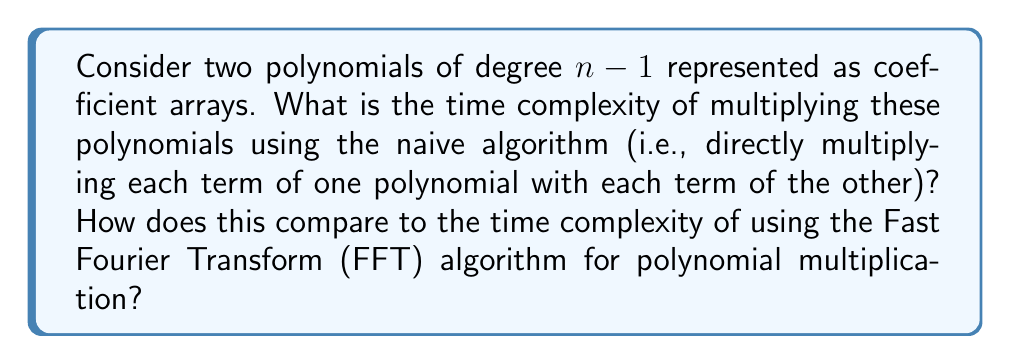Show me your answer to this math problem. To analyze the time complexity of polynomial multiplication algorithms, we need to consider the number of operations performed:

1. Naive Algorithm:
   - For two polynomials of degree $n-1$, we have $n$ coefficients in each polynomial.
   - We need to multiply each coefficient of the first polynomial with each coefficient of the second polynomial.
   - This results in $n \times n = n^2$ multiplications.
   - We also need to sum up the products for each resulting coefficient, which takes $O(n^2)$ additions.
   - Therefore, the total time complexity is $O(n^2)$.

2. Fast Fourier Transform (FFT) Algorithm:
   - The FFT algorithm converts the polynomials to point-value representation.
   - It then performs pointwise multiplication and converts back to coefficient representation.
   - The steps are:
     a) Apply FFT to both polynomials: $O(n \log n)$ each
     b) Multiply the resulting points: $O(n)$
     c) Apply inverse FFT to get the result: $O(n \log n)$
   - The total time complexity is $O(n \log n)$.

Comparison:
- The naive algorithm has a time complexity of $O(n^2)$.
- The FFT algorithm has a time complexity of $O(n \log n)$.
- As $n$ grows larger, the FFT algorithm becomes significantly faster than the naive algorithm.
- For example, when $n = 1,000,000$:
  - Naive: $O(10^{12})$ operations
  - FFT: $O(2 \times 10^7)$ operations (approximately)

This demonstrates why the FFT algorithm is preferred for large-scale polynomial multiplication, especially in applications like big integer arithmetic or signal processing.
Answer: The time complexity of the naive polynomial multiplication algorithm is $O(n^2)$, while the time complexity of the FFT-based algorithm is $O(n \log n)$. The FFT algorithm is asymptotically faster for large $n$. 